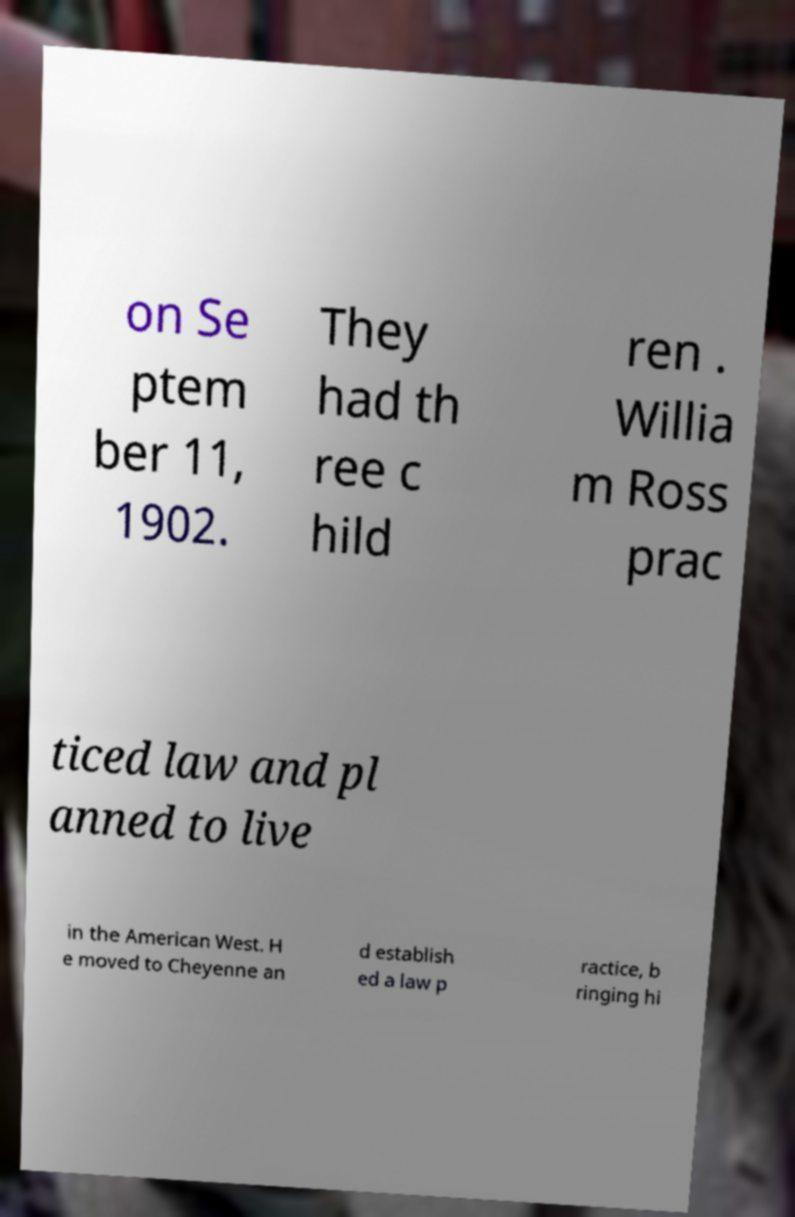What messages or text are displayed in this image? I need them in a readable, typed format. on Se ptem ber 11, 1902. They had th ree c hild ren . Willia m Ross prac ticed law and pl anned to live in the American West. H e moved to Cheyenne an d establish ed a law p ractice, b ringing hi 